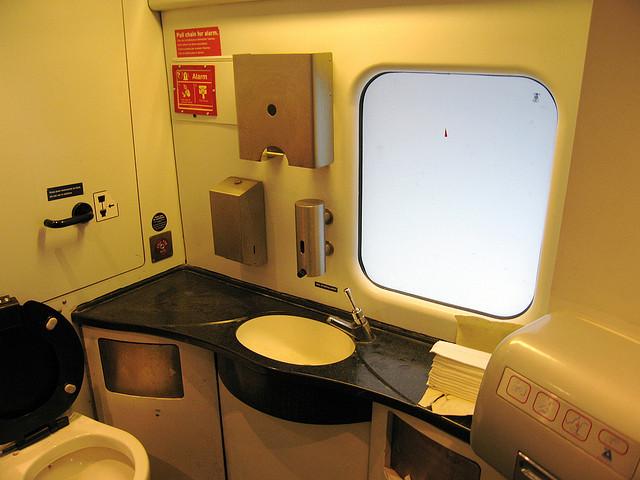What room are they in?
Answer briefly. Bathroom. Is this bathroom in a house?
Quick response, please. No. Are there any paper towels on the sink?
Answer briefly. Yes. 